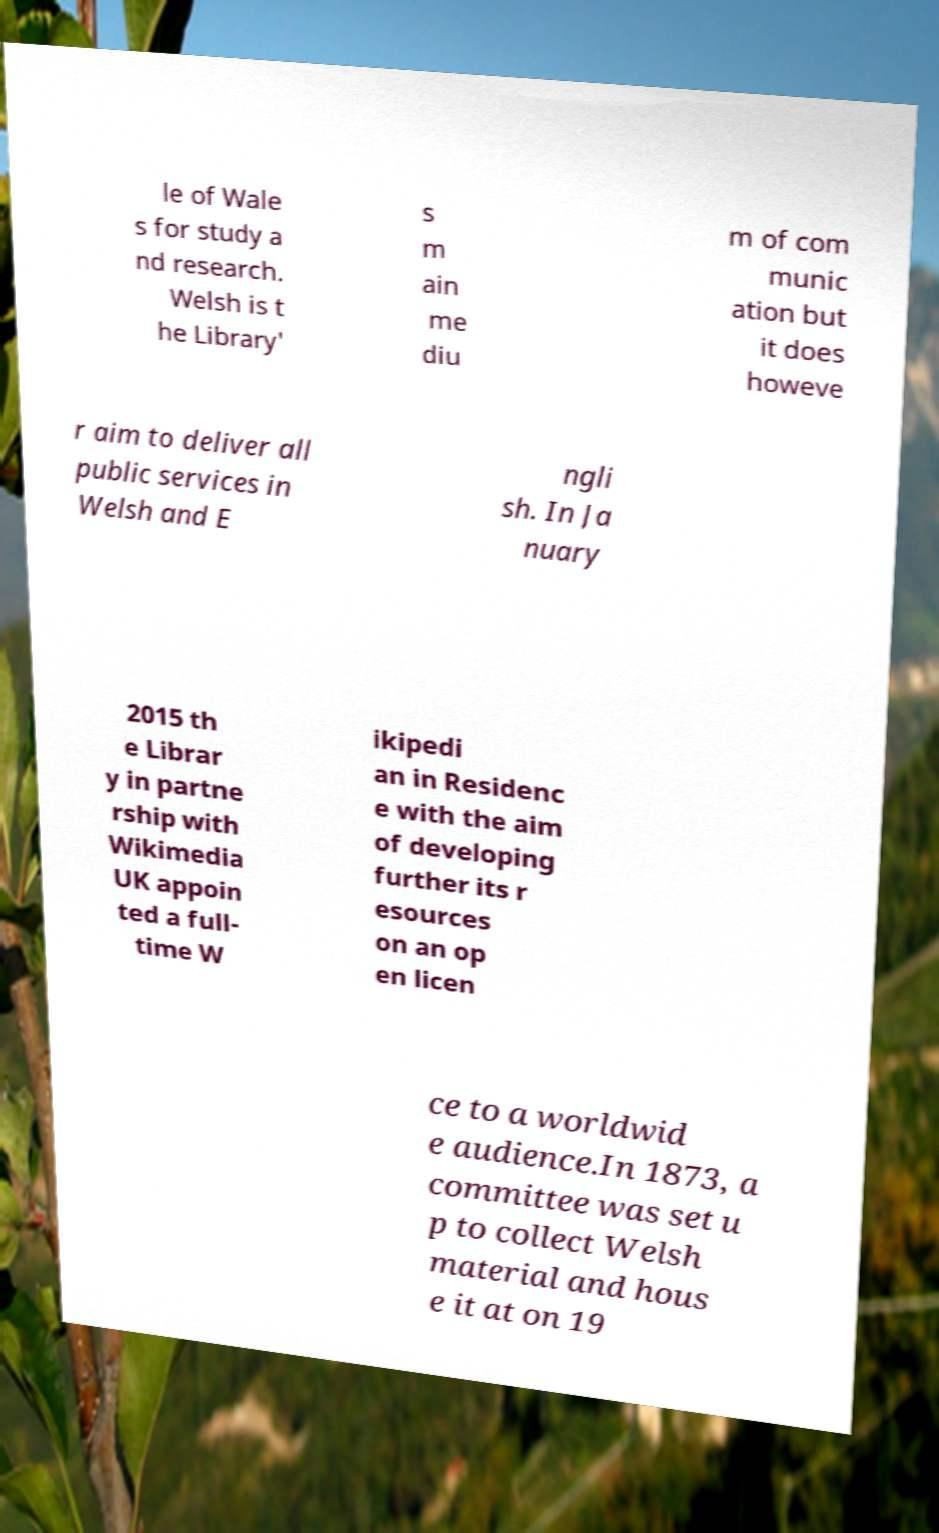Please identify and transcribe the text found in this image. le of Wale s for study a nd research. Welsh is t he Library' s m ain me diu m of com munic ation but it does howeve r aim to deliver all public services in Welsh and E ngli sh. In Ja nuary 2015 th e Librar y in partne rship with Wikimedia UK appoin ted a full- time W ikipedi an in Residenc e with the aim of developing further its r esources on an op en licen ce to a worldwid e audience.In 1873, a committee was set u p to collect Welsh material and hous e it at on 19 